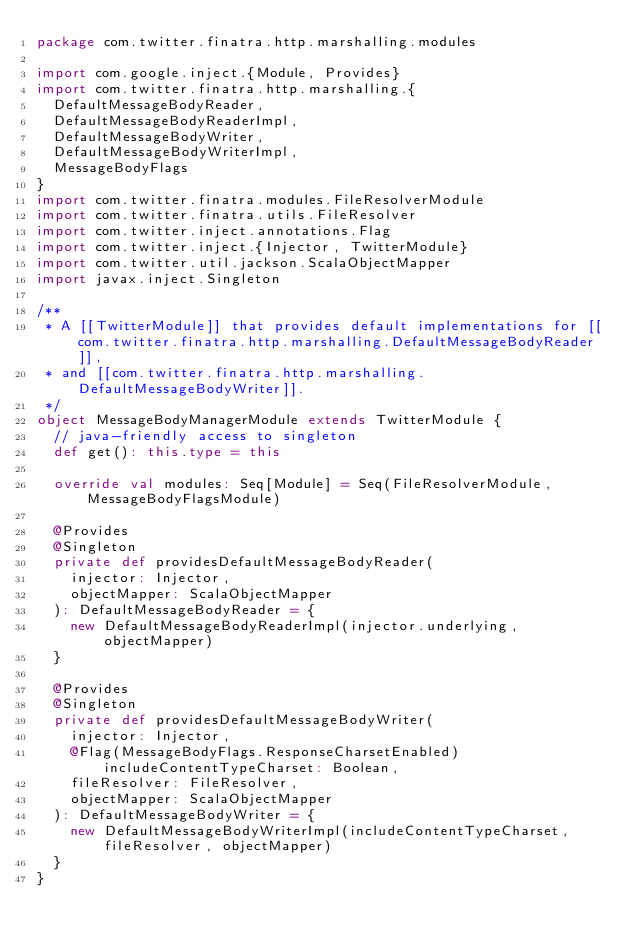Convert code to text. <code><loc_0><loc_0><loc_500><loc_500><_Scala_>package com.twitter.finatra.http.marshalling.modules

import com.google.inject.{Module, Provides}
import com.twitter.finatra.http.marshalling.{
  DefaultMessageBodyReader,
  DefaultMessageBodyReaderImpl,
  DefaultMessageBodyWriter,
  DefaultMessageBodyWriterImpl,
  MessageBodyFlags
}
import com.twitter.finatra.modules.FileResolverModule
import com.twitter.finatra.utils.FileResolver
import com.twitter.inject.annotations.Flag
import com.twitter.inject.{Injector, TwitterModule}
import com.twitter.util.jackson.ScalaObjectMapper
import javax.inject.Singleton

/**
 * A [[TwitterModule]] that provides default implementations for [[com.twitter.finatra.http.marshalling.DefaultMessageBodyReader]],
 * and [[com.twitter.finatra.http.marshalling.DefaultMessageBodyWriter]].
 */
object MessageBodyManagerModule extends TwitterModule {
  // java-friendly access to singleton
  def get(): this.type = this

  override val modules: Seq[Module] = Seq(FileResolverModule, MessageBodyFlagsModule)

  @Provides
  @Singleton
  private def providesDefaultMessageBodyReader(
    injector: Injector,
    objectMapper: ScalaObjectMapper
  ): DefaultMessageBodyReader = {
    new DefaultMessageBodyReaderImpl(injector.underlying, objectMapper)
  }

  @Provides
  @Singleton
  private def providesDefaultMessageBodyWriter(
    injector: Injector,
    @Flag(MessageBodyFlags.ResponseCharsetEnabled) includeContentTypeCharset: Boolean,
    fileResolver: FileResolver,
    objectMapper: ScalaObjectMapper
  ): DefaultMessageBodyWriter = {
    new DefaultMessageBodyWriterImpl(includeContentTypeCharset, fileResolver, objectMapper)
  }
}
</code> 